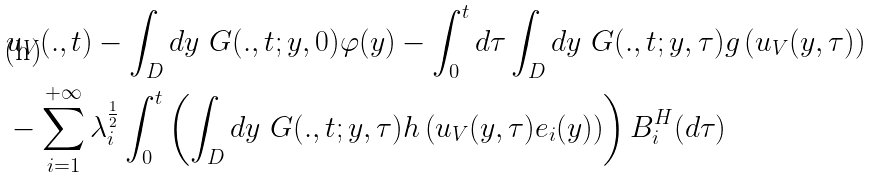<formula> <loc_0><loc_0><loc_500><loc_500>& u _ { V } ( . , t ) - \int _ { D } d y \ G ( . , t ; y , 0 ) \varphi ( y ) - \int _ { 0 } ^ { t } d \tau \int _ { D } d y \ G ( . , t ; y , \tau ) g \left ( u _ { V } ( y , \tau ) \right ) \\ & - \sum _ { i = 1 } ^ { + \infty } \lambda _ { i } ^ { \frac { 1 } { 2 } } \int _ { 0 } ^ { t } \left ( \int _ { D } d y \ G ( . , t ; y , \tau ) h \left ( u _ { V } ( y , \tau ) e _ { i } ( y ) \right ) \right ) B _ { i } ^ { H } ( d \tau )</formula> 